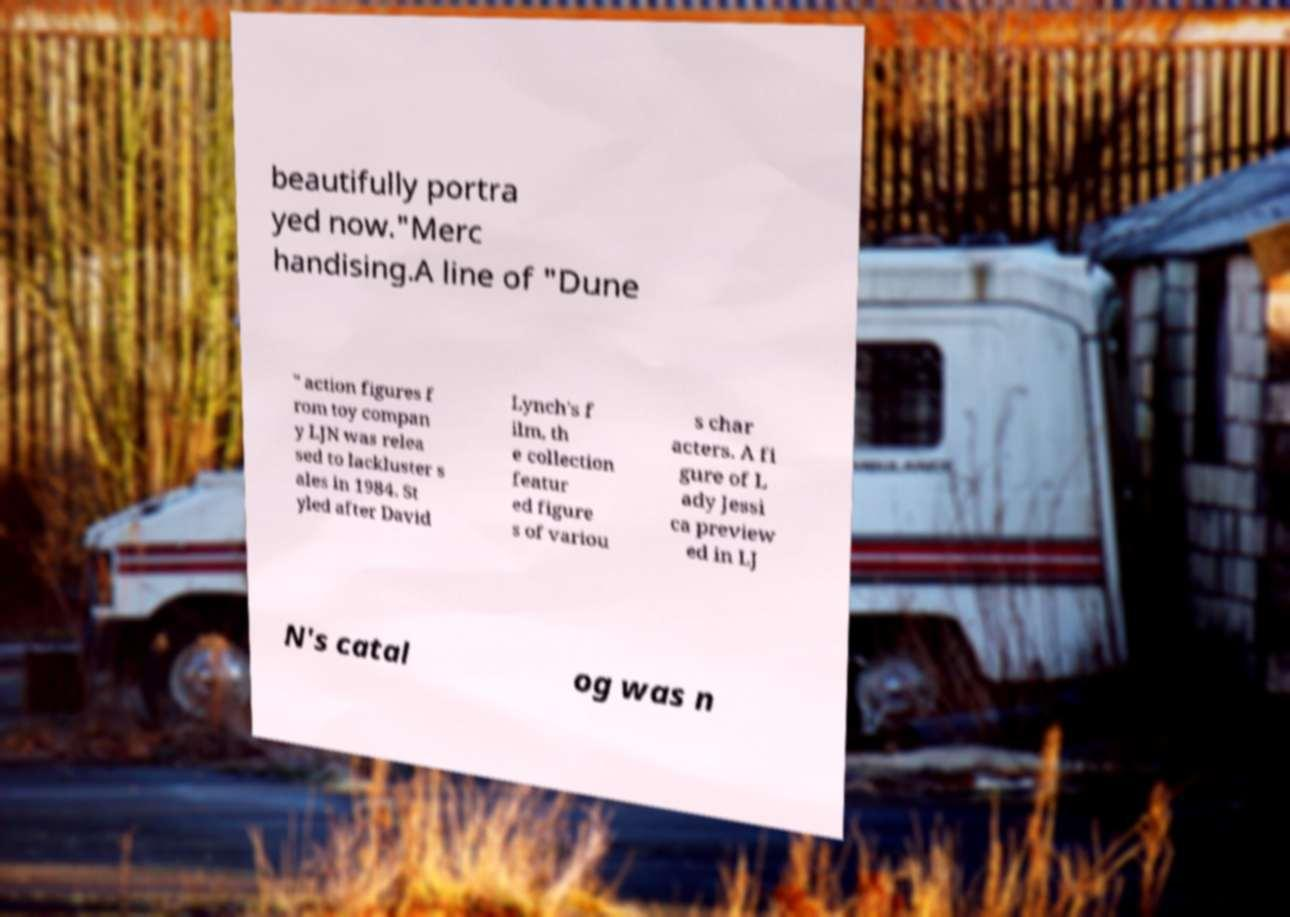Could you extract and type out the text from this image? beautifully portra yed now."Merc handising.A line of "Dune " action figures f rom toy compan y LJN was relea sed to lackluster s ales in 1984. St yled after David Lynch's f ilm, th e collection featur ed figure s of variou s char acters. A fi gure of L ady Jessi ca preview ed in LJ N's catal og was n 